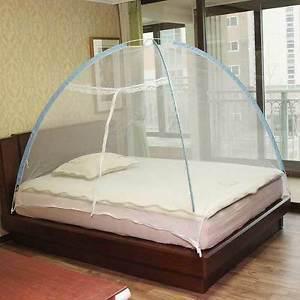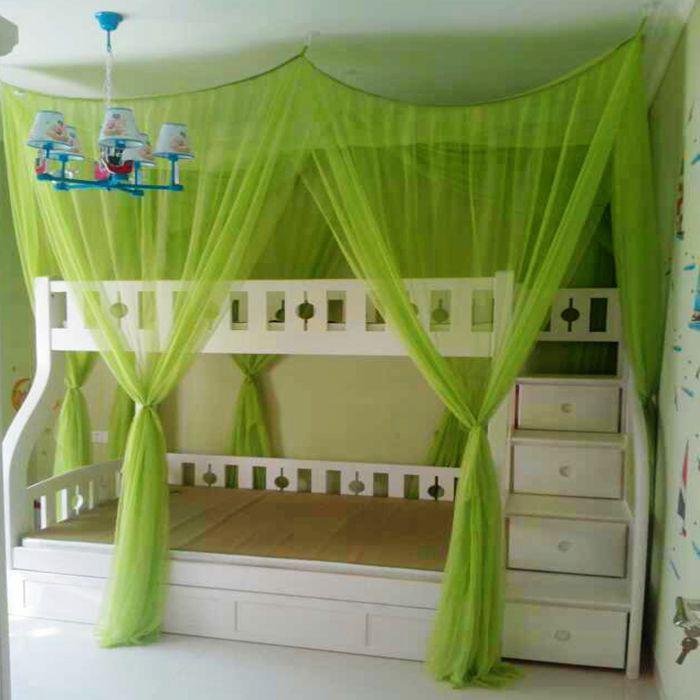The first image is the image on the left, the second image is the image on the right. Assess this claim about the two images: "The bed covering in one image is igloo shaped with green ribbing details.". Correct or not? Answer yes or no. No. The first image is the image on the left, the second image is the image on the right. Considering the images on both sides, is "In the image to the left, the bed canopy is closed." valid? Answer yes or no. Yes. 